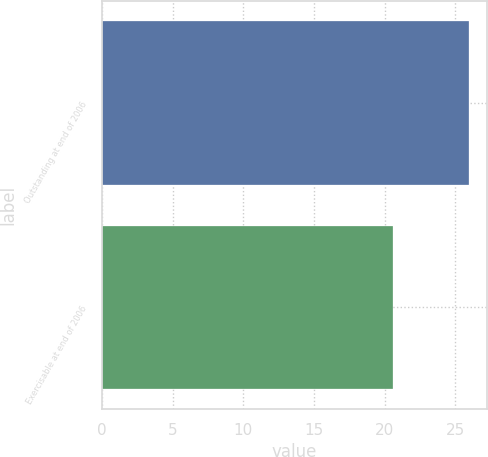Convert chart to OTSL. <chart><loc_0><loc_0><loc_500><loc_500><bar_chart><fcel>Outstanding at end of 2006<fcel>Exercisable at end of 2006<nl><fcel>25.97<fcel>20.6<nl></chart> 